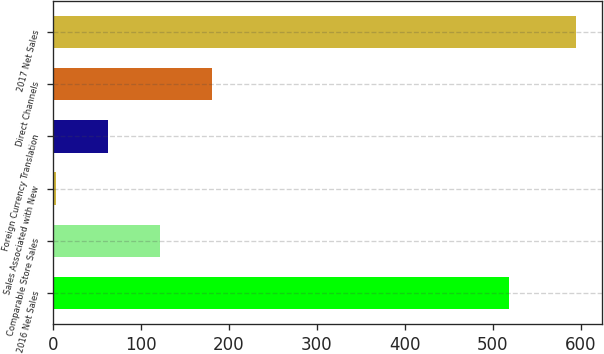<chart> <loc_0><loc_0><loc_500><loc_500><bar_chart><fcel>2016 Net Sales<fcel>Comparable Store Sales<fcel>Sales Associated with New<fcel>Foreign Currency Translation<fcel>Direct Channels<fcel>2017 Net Sales<nl><fcel>518<fcel>121.4<fcel>3<fcel>62.2<fcel>180.6<fcel>595<nl></chart> 